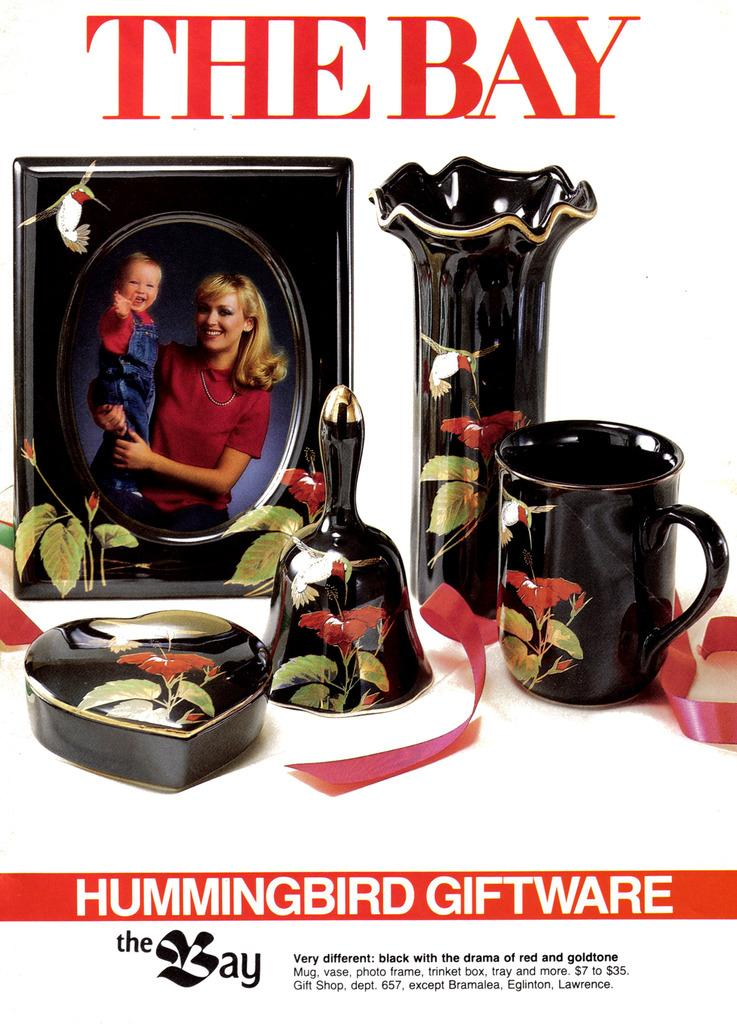Provide a one-sentence caption for the provided image. An advertisement for Hummingbird Giftware shows various black porcelain items. 